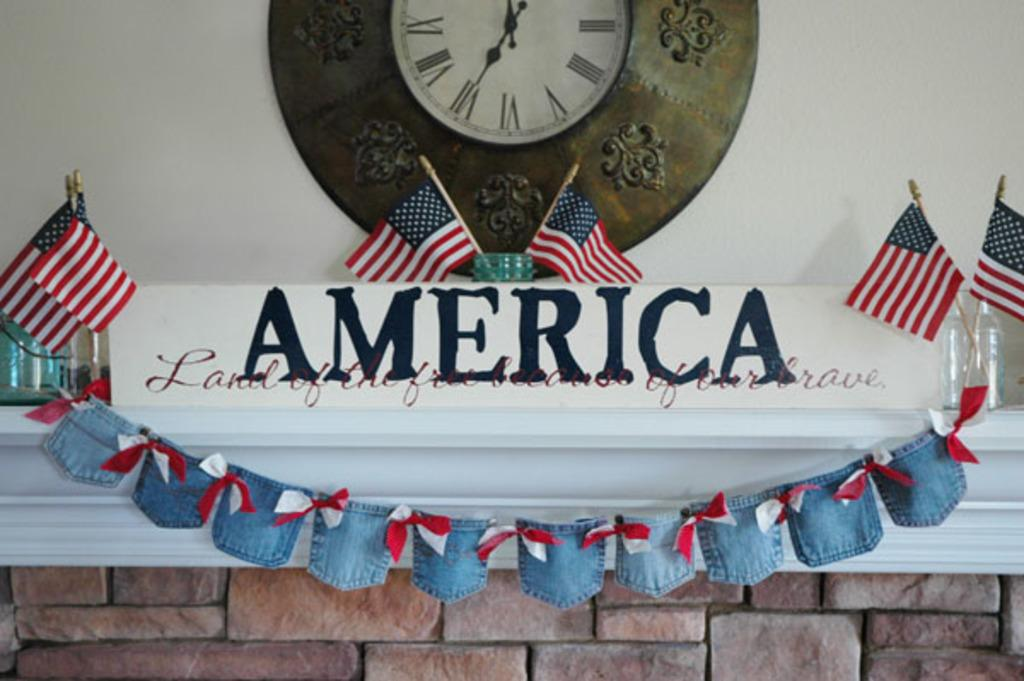<image>
Write a terse but informative summary of the picture. A clock with Roman numerals in front of a sign reading America. 